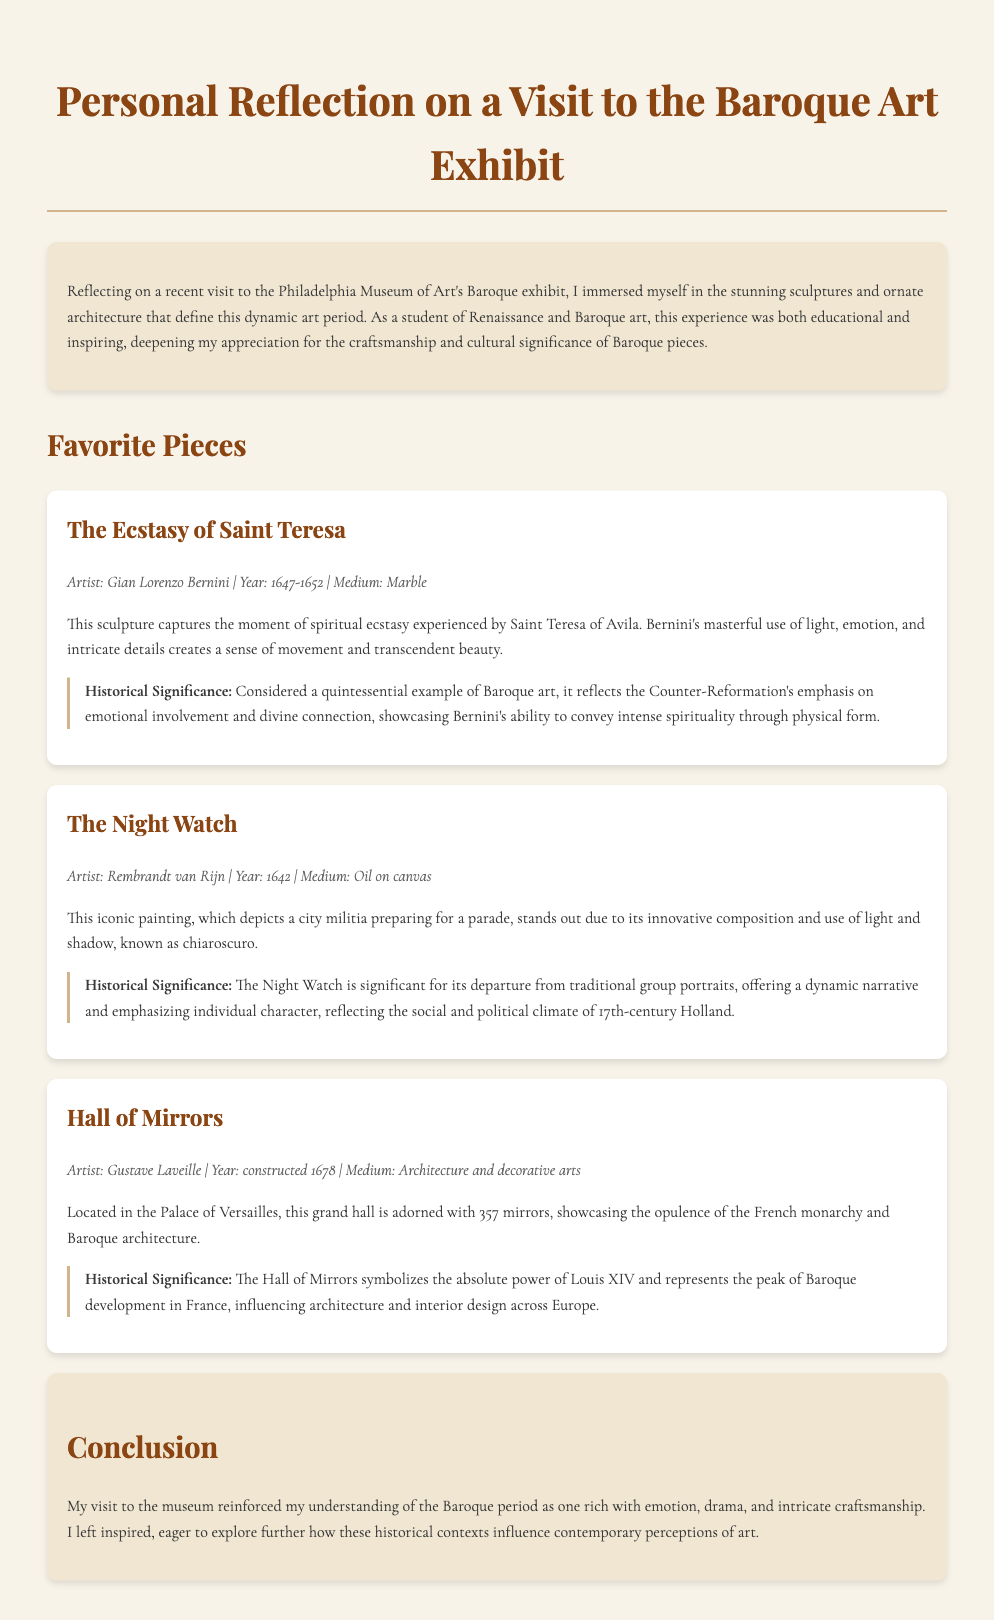what is the title of the sculpture by Gian Lorenzo Bernini? The title of the sculpture is located in the section discussing favorite pieces, specifically mentioning that it is "The Ecstasy of Saint Teresa."
Answer: The Ecstasy of Saint Teresa who is the artist of The Night Watch? The artist of The Night Watch is listed in the details of the work, which states "Artist: Rembrandt van Rijn."
Answer: Rembrandt van Rijn what year was The Night Watch completed? The year of completion for The Night Watch can be found in the artwork details section stating "Year: 1642."
Answer: 1642 how many mirrors are in the Hall of Mirrors? The number of mirrors is specified in the description of the Hall of Mirrors, stating "adorned with 357 mirrors."
Answer: 357 what is the primary medium of The Ecstasy of Saint Teresa? The primary medium for The Ecstasy of Saint Teresa is mentioned as "Medium: Marble."
Answer: Marble what does the Hall of Mirrors symbolize? The symbolism is described within the context of the Hall of Mirrors, stating it "symbolizes the absolute power of Louis XIV."
Answer: absolute power of Louis XIV what technique is highlighted in The Night Watch? The technique used in The Night Watch is mentioned as "use of light and shadow, known as chiaroscuro."
Answer: chiaroscuro which historical event influenced The Ecstasy of Saint Teresa? The historical event influencing it is "the Counter-Reformation's emphasis on emotional involvement."
Answer: Counter-Reformation what is the overarching theme of the document's conclusion? The overarching theme is summarized in the conclusion noting the rich emotions and craftsmanship, thus reinforcing the understanding of the Baroque period.
Answer: rich with emotion, drama, and intricate craftsmanship 